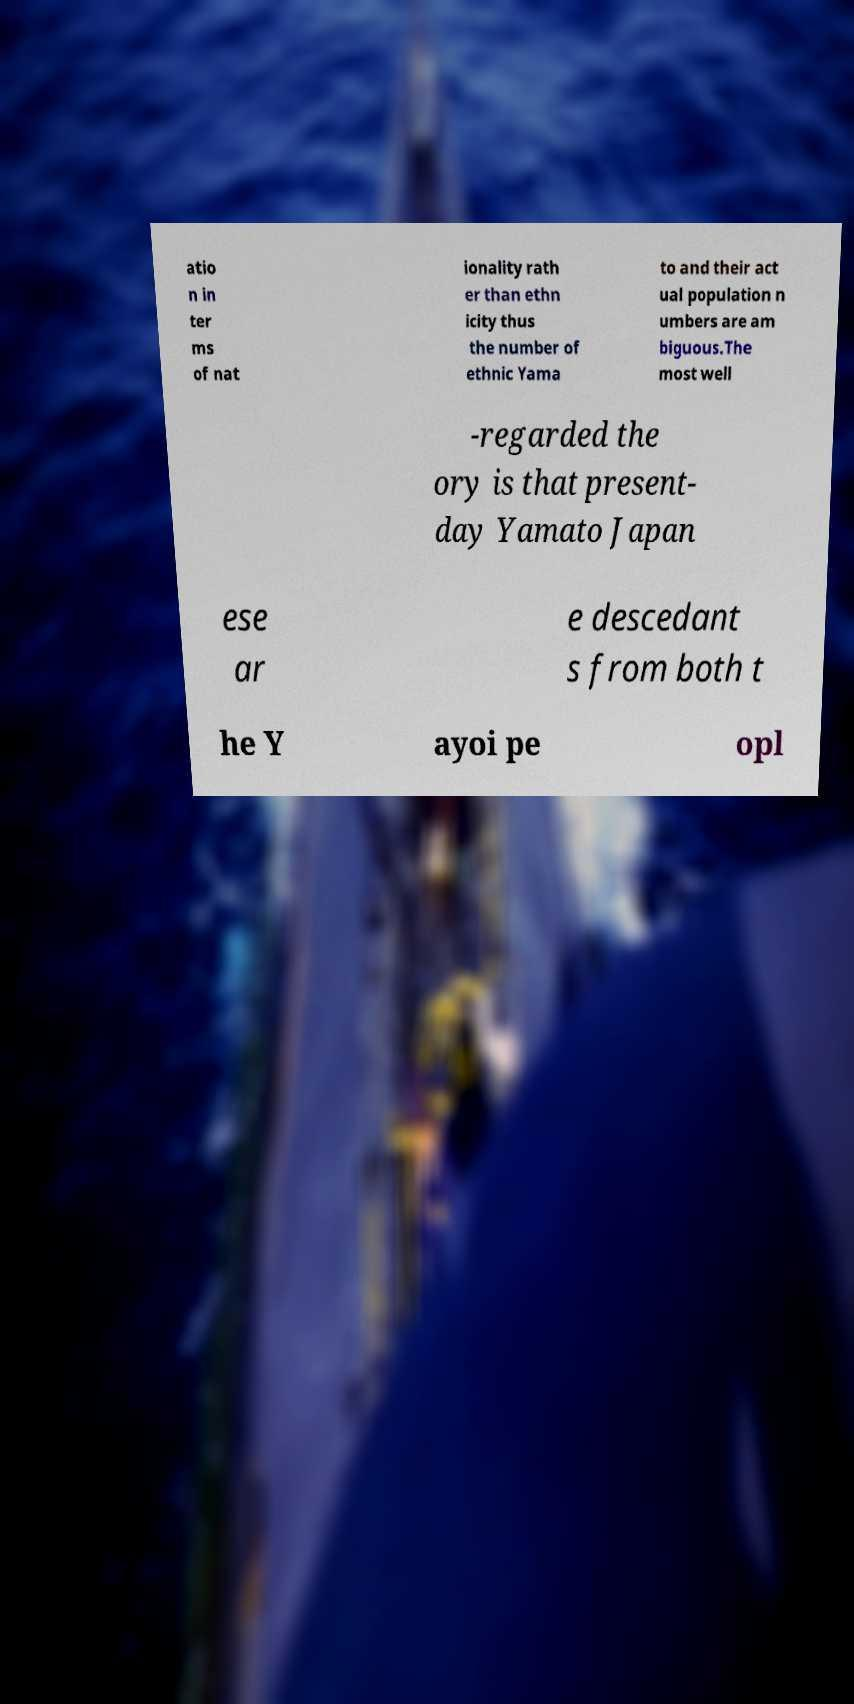Please identify and transcribe the text found in this image. atio n in ter ms of nat ionality rath er than ethn icity thus the number of ethnic Yama to and their act ual population n umbers are am biguous.The most well -regarded the ory is that present- day Yamato Japan ese ar e descedant s from both t he Y ayoi pe opl 